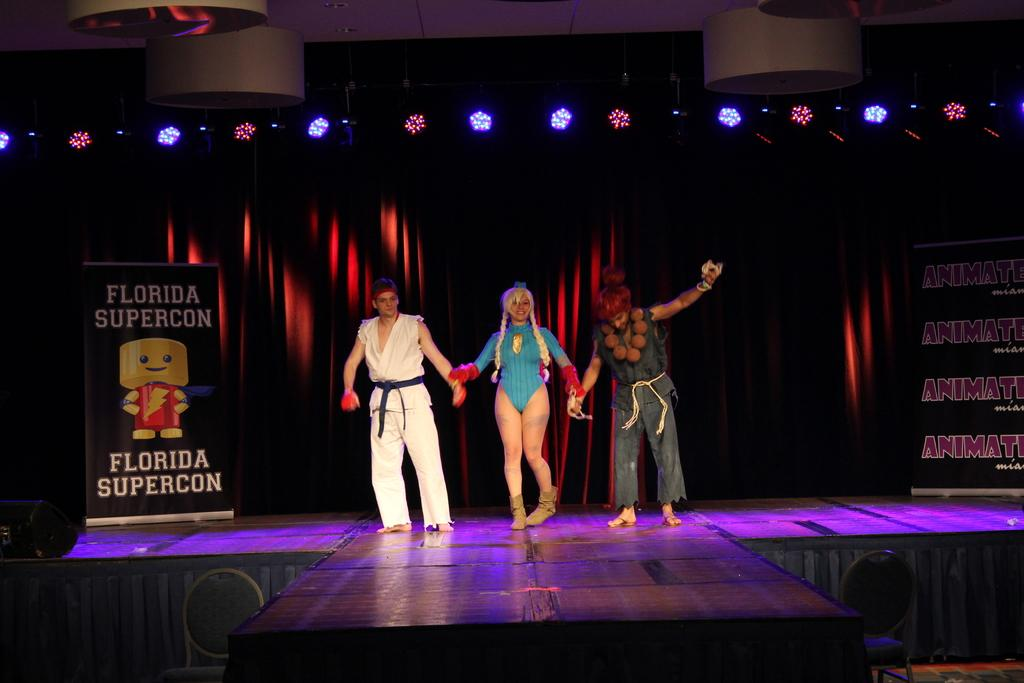<image>
Summarize the visual content of the image. Three costumed people on stage holding hands at Florida Supercon. 